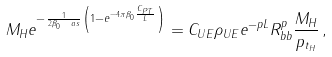<formula> <loc_0><loc_0><loc_500><loc_500>M _ { H } e ^ { - \frac { 1 } { 2 \beta _ { 0 } \ a s } \left ( 1 - e ^ { - 4 \pi \beta _ { 0 } \frac { C _ { P T } } { L } } \right ) } = C _ { U E } \rho _ { U E } e ^ { - p L } R _ { b b } ^ { p } \frac { M _ { H } } { p _ { t _ { H } } } \, ,</formula> 